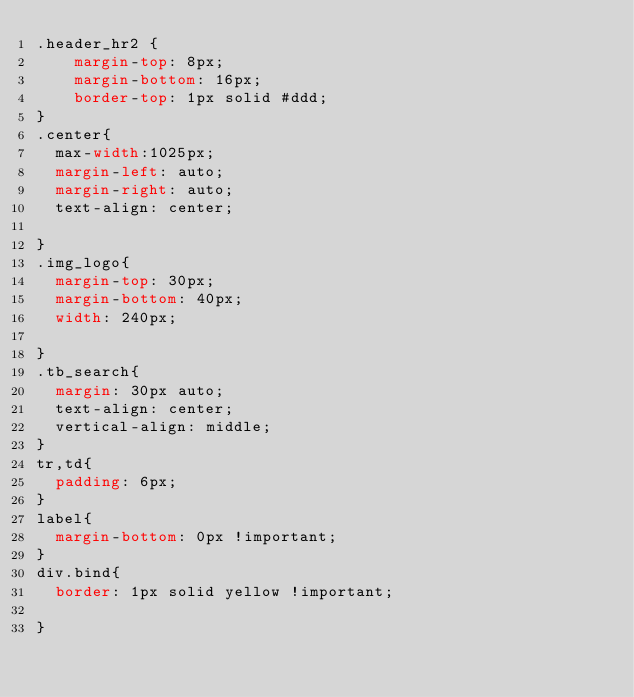<code> <loc_0><loc_0><loc_500><loc_500><_CSS_>.header_hr2 {
    margin-top: 8px;
    margin-bottom: 16px;
    border-top: 1px solid #ddd;
}
.center{	
	max-width:1025px;
	margin-left: auto;
	margin-right: auto;
	text-align: center;
	
}
.img_logo{
	margin-top: 30px;
	margin-bottom: 40px;
	width: 240px;
	
}
.tb_search{
	margin: 30px auto;
	text-align: center;
	vertical-align: middle;
}
tr,td{
	padding: 6px;
}
label{
	margin-bottom: 0px !important;
}
div.bind{
	border: 1px solid yellow !important; 

}
</code> 